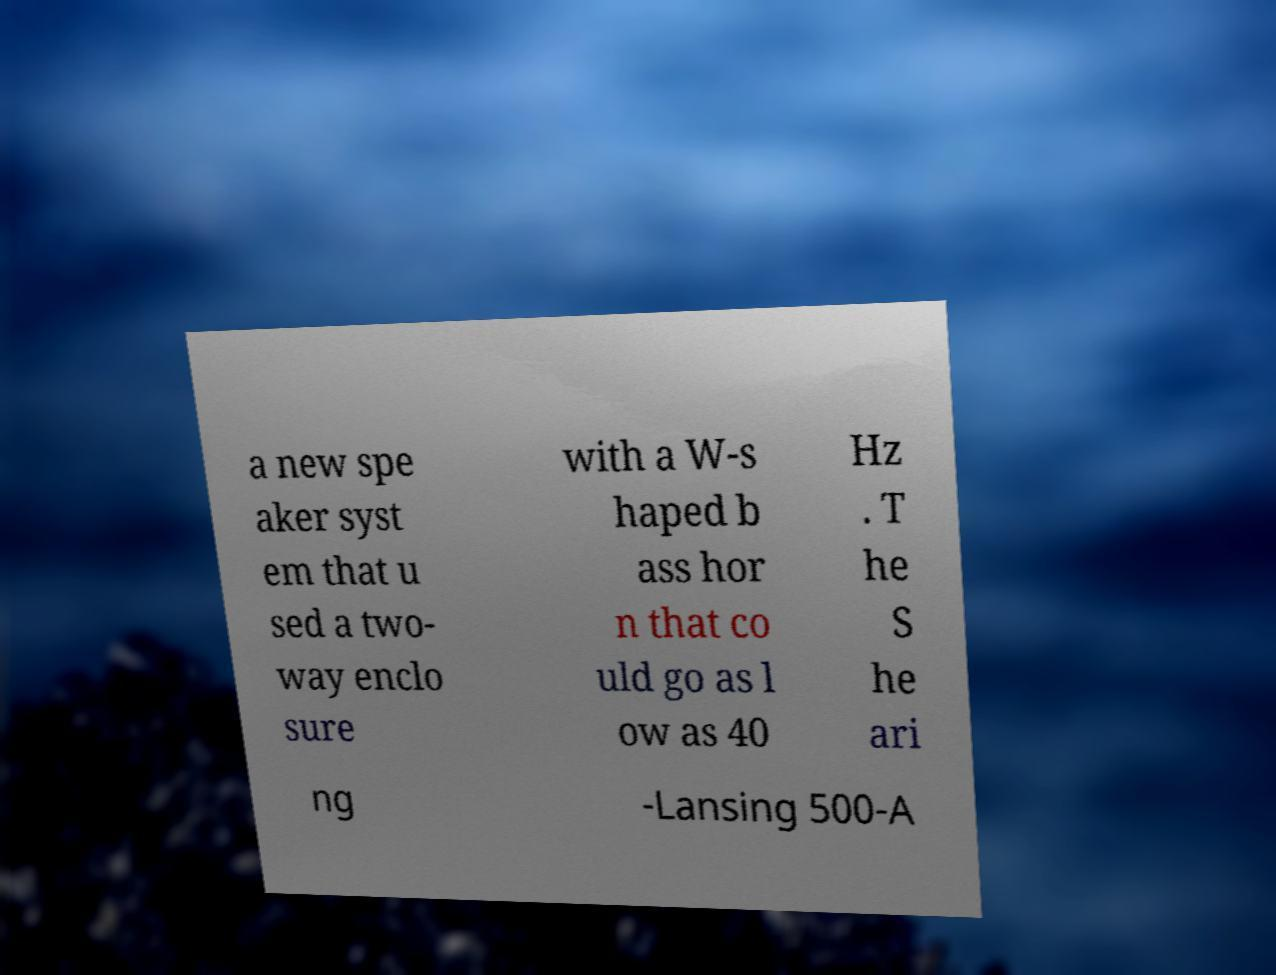What messages or text are displayed in this image? I need them in a readable, typed format. a new spe aker syst em that u sed a two- way enclo sure with a W-s haped b ass hor n that co uld go as l ow as 40 Hz . T he S he ari ng -Lansing 500-A 